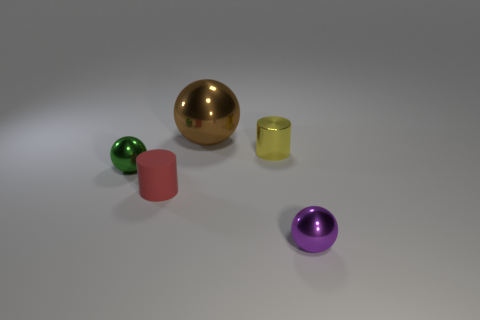Add 4 small brown spheres. How many objects exist? 9 Subtract all cylinders. How many objects are left? 3 Subtract 0 blue cylinders. How many objects are left? 5 Subtract all big purple rubber objects. Subtract all tiny purple shiny things. How many objects are left? 4 Add 2 small green things. How many small green things are left? 3 Add 5 tiny matte cylinders. How many tiny matte cylinders exist? 6 